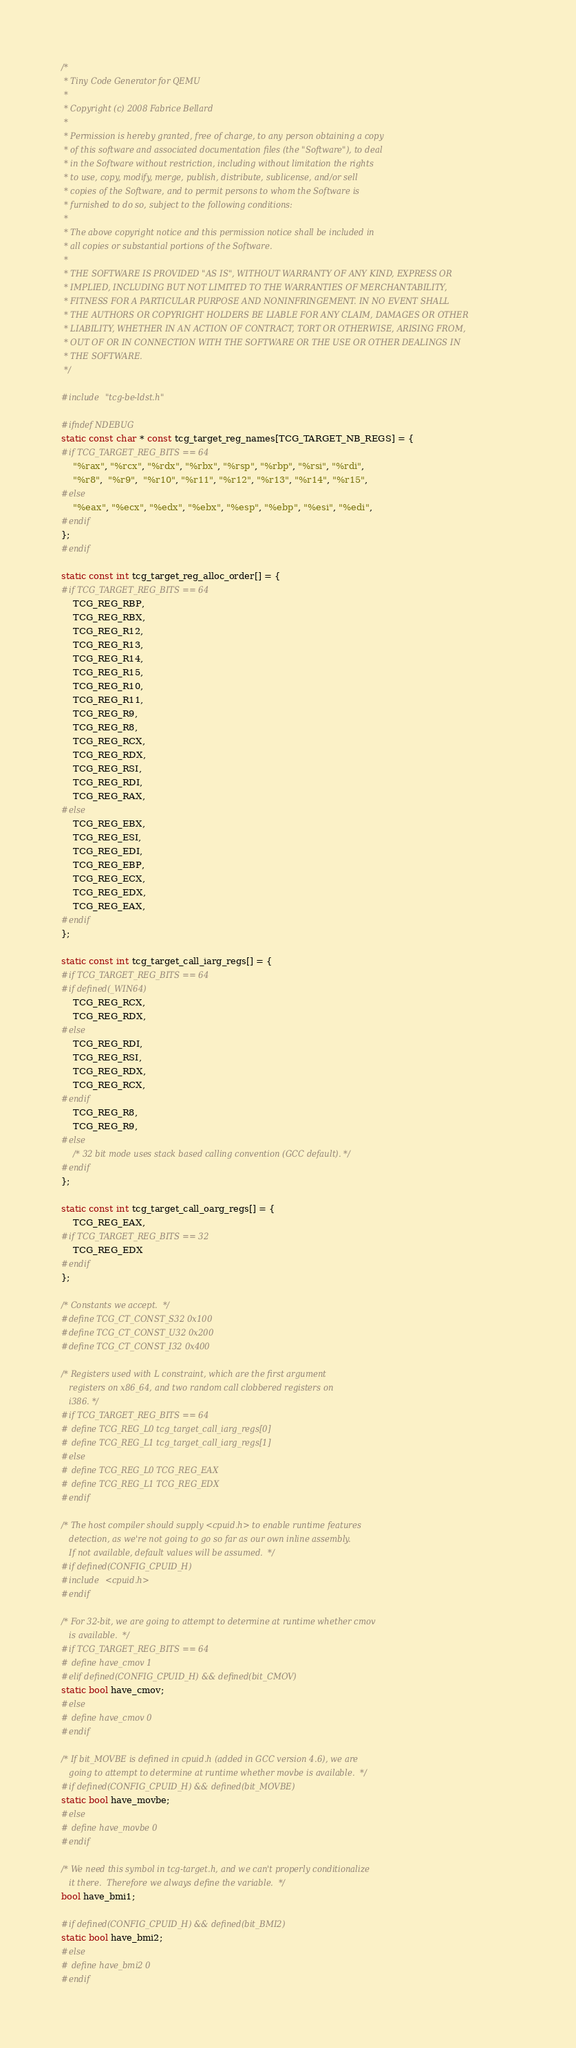Convert code to text. <code><loc_0><loc_0><loc_500><loc_500><_C_>/*
 * Tiny Code Generator for QEMU
 *
 * Copyright (c) 2008 Fabrice Bellard
 *
 * Permission is hereby granted, free of charge, to any person obtaining a copy
 * of this software and associated documentation files (the "Software"), to deal
 * in the Software without restriction, including without limitation the rights
 * to use, copy, modify, merge, publish, distribute, sublicense, and/or sell
 * copies of the Software, and to permit persons to whom the Software is
 * furnished to do so, subject to the following conditions:
 *
 * The above copyright notice and this permission notice shall be included in
 * all copies or substantial portions of the Software.
 *
 * THE SOFTWARE IS PROVIDED "AS IS", WITHOUT WARRANTY OF ANY KIND, EXPRESS OR
 * IMPLIED, INCLUDING BUT NOT LIMITED TO THE WARRANTIES OF MERCHANTABILITY,
 * FITNESS FOR A PARTICULAR PURPOSE AND NONINFRINGEMENT. IN NO EVENT SHALL
 * THE AUTHORS OR COPYRIGHT HOLDERS BE LIABLE FOR ANY CLAIM, DAMAGES OR OTHER
 * LIABILITY, WHETHER IN AN ACTION OF CONTRACT, TORT OR OTHERWISE, ARISING FROM,
 * OUT OF OR IN CONNECTION WITH THE SOFTWARE OR THE USE OR OTHER DEALINGS IN
 * THE SOFTWARE.
 */

#include "tcg-be-ldst.h"

#ifndef NDEBUG
static const char * const tcg_target_reg_names[TCG_TARGET_NB_REGS] = {
#if TCG_TARGET_REG_BITS == 64
    "%rax", "%rcx", "%rdx", "%rbx", "%rsp", "%rbp", "%rsi", "%rdi",
    "%r8",  "%r9",  "%r10", "%r11", "%r12", "%r13", "%r14", "%r15",
#else
    "%eax", "%ecx", "%edx", "%ebx", "%esp", "%ebp", "%esi", "%edi",
#endif
};
#endif

static const int tcg_target_reg_alloc_order[] = {
#if TCG_TARGET_REG_BITS == 64
    TCG_REG_RBP,
    TCG_REG_RBX,
    TCG_REG_R12,
    TCG_REG_R13,
    TCG_REG_R14,
    TCG_REG_R15,
    TCG_REG_R10,
    TCG_REG_R11,
    TCG_REG_R9,
    TCG_REG_R8,
    TCG_REG_RCX,
    TCG_REG_RDX,
    TCG_REG_RSI,
    TCG_REG_RDI,
    TCG_REG_RAX,
#else
    TCG_REG_EBX,
    TCG_REG_ESI,
    TCG_REG_EDI,
    TCG_REG_EBP,
    TCG_REG_ECX,
    TCG_REG_EDX,
    TCG_REG_EAX,
#endif
};

static const int tcg_target_call_iarg_regs[] = {
#if TCG_TARGET_REG_BITS == 64
#if defined(_WIN64)
    TCG_REG_RCX,
    TCG_REG_RDX,
#else
    TCG_REG_RDI,
    TCG_REG_RSI,
    TCG_REG_RDX,
    TCG_REG_RCX,
#endif
    TCG_REG_R8,
    TCG_REG_R9,
#else
    /* 32 bit mode uses stack based calling convention (GCC default). */
#endif
};

static const int tcg_target_call_oarg_regs[] = {
    TCG_REG_EAX,
#if TCG_TARGET_REG_BITS == 32
    TCG_REG_EDX
#endif
};

/* Constants we accept.  */
#define TCG_CT_CONST_S32 0x100
#define TCG_CT_CONST_U32 0x200
#define TCG_CT_CONST_I32 0x400

/* Registers used with L constraint, which are the first argument 
   registers on x86_64, and two random call clobbered registers on
   i386. */
#if TCG_TARGET_REG_BITS == 64
# define TCG_REG_L0 tcg_target_call_iarg_regs[0]
# define TCG_REG_L1 tcg_target_call_iarg_regs[1]
#else
# define TCG_REG_L0 TCG_REG_EAX
# define TCG_REG_L1 TCG_REG_EDX
#endif

/* The host compiler should supply <cpuid.h> to enable runtime features
   detection, as we're not going to go so far as our own inline assembly.
   If not available, default values will be assumed.  */
#if defined(CONFIG_CPUID_H)
#include <cpuid.h>
#endif

/* For 32-bit, we are going to attempt to determine at runtime whether cmov
   is available.  */
#if TCG_TARGET_REG_BITS == 64
# define have_cmov 1
#elif defined(CONFIG_CPUID_H) && defined(bit_CMOV)
static bool have_cmov;
#else
# define have_cmov 0
#endif

/* If bit_MOVBE is defined in cpuid.h (added in GCC version 4.6), we are
   going to attempt to determine at runtime whether movbe is available.  */
#if defined(CONFIG_CPUID_H) && defined(bit_MOVBE)
static bool have_movbe;
#else
# define have_movbe 0
#endif

/* We need this symbol in tcg-target.h, and we can't properly conditionalize
   it there.  Therefore we always define the variable.  */
bool have_bmi1;

#if defined(CONFIG_CPUID_H) && defined(bit_BMI2)
static bool have_bmi2;
#else
# define have_bmi2 0
#endif
</code> 